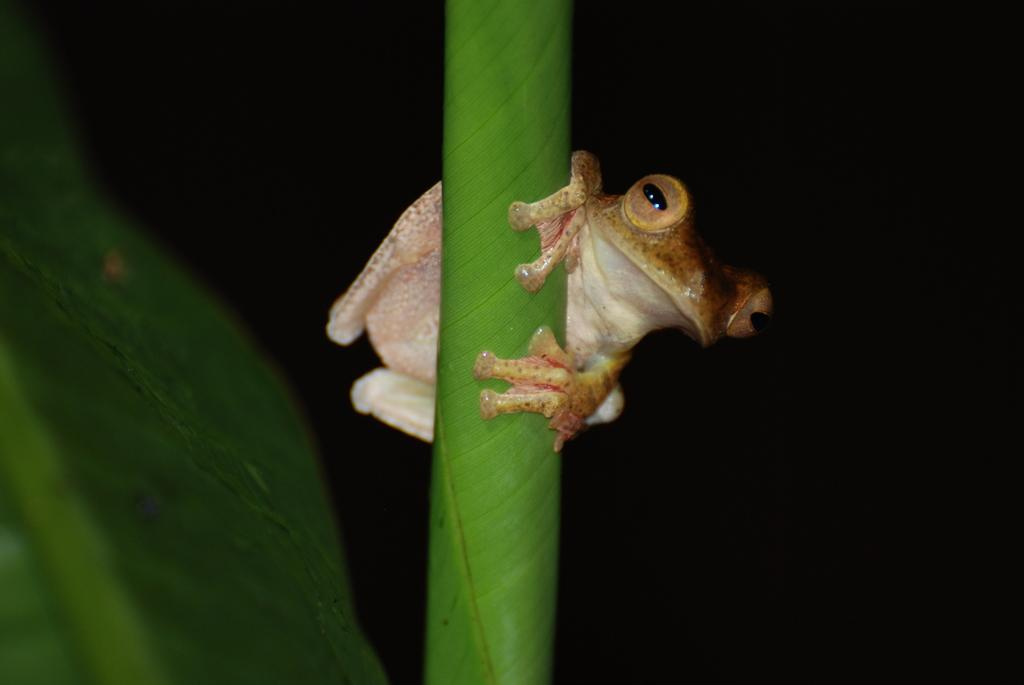What animal is present in the image? There is a frog in the image. Where is the frog located? The frog is on a leaf. What type of cap is the frog wearing in the image? There is no cap present in the image; the frog is not wearing any clothing. 